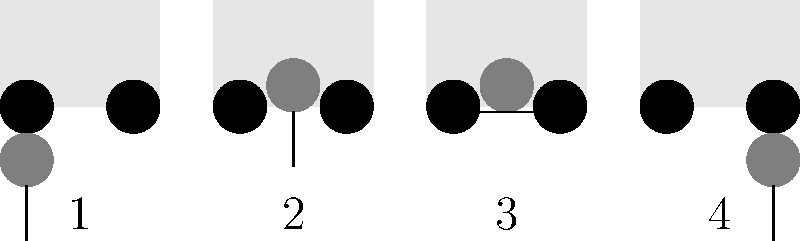Which image represents the correct final step in safely assisting a senior citizen out of a vehicle? Let's analyze each step in the sequence:

1. Image 1: The senior citizen is standing next to the vehicle, not yet ready to enter.
2. Image 2: The caregiver is assisting the senior citizen into the vehicle.
3. Image 3: The senior citizen is seated inside the vehicle.
4. Image 4: The caregiver is assisting the senior citizen out of the vehicle.

The question asks for the final step in assisting a senior citizen out of a vehicle. This process typically involves:

1. Opening the car door
2. Ensuring the senior is ready to exit
3. Offering support as they turn in their seat
4. Assisting them as they stand up and step out of the vehicle

Image 4 shows the caregiver supporting the senior citizen as they step out of the vehicle, which represents the final step in this process.
Answer: 4 